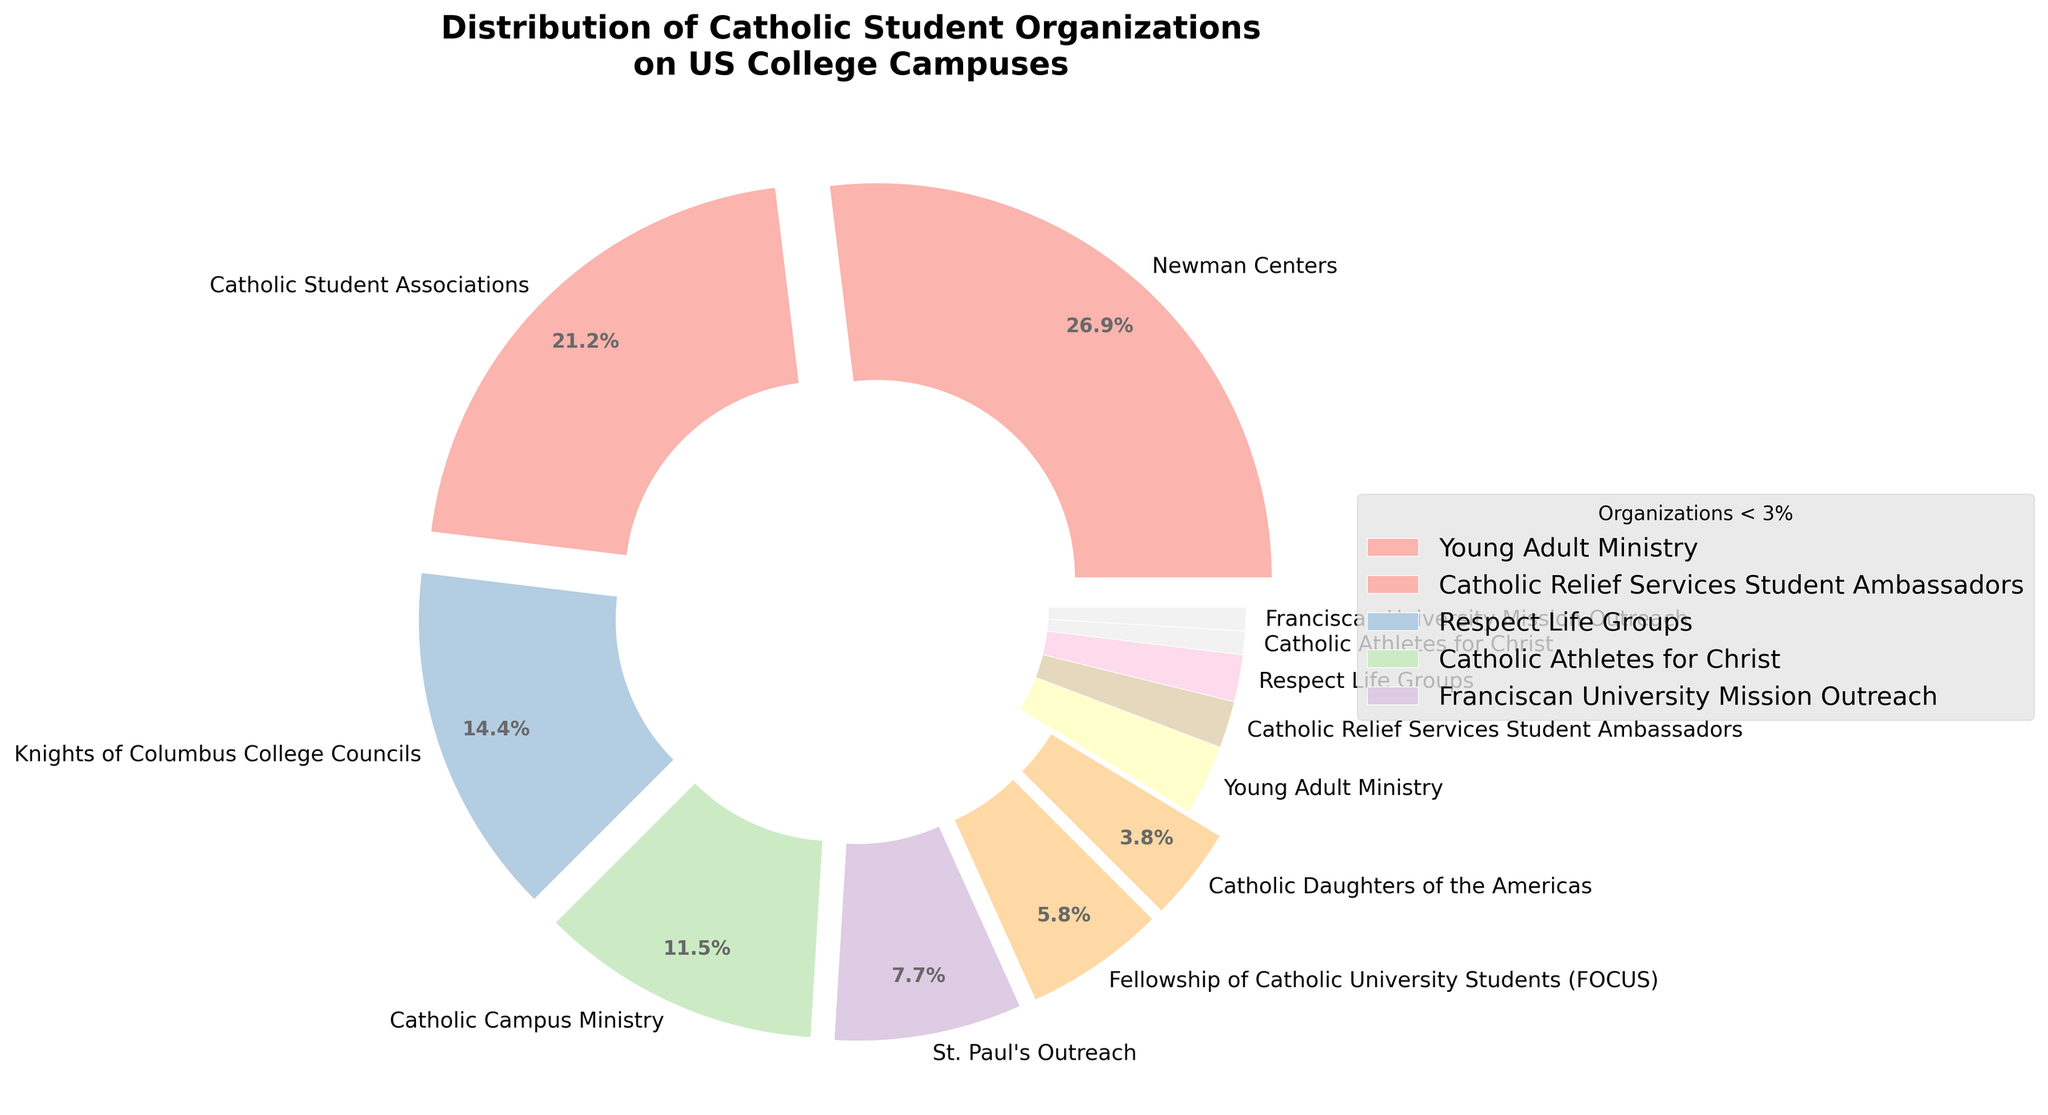Which organization type has the highest percentage? The organization type with the highest percentage is directly visible from the largest wedge of the pie chart.
Answer: Newman Centers What is the combined percentage of Newman Centers and Catholic Student Associations? Add the percentage of Newman Centers (28%) and Catholic Student Associations (22%). 28 + 22 = 50
Answer: 50% Which organizations have a percentage of 2% or less? The legend and the labels on the pie chart identify organizations with a percentage of 2% or less. These are: Catholic Relief Services Student Ambassadors (2%), Respect Life Groups (2%), Catholic Athletes for Christ (1%), Franciscan University Mission Outreach (1%).
Answer: Catholic Relief Services Student Ambassadors, Respect Life Groups, Catholic Athletes for Christ, Franciscan University Mission Outreach Which organization types have their wedges "exploded" or slightly separated from the pie chart? The exploded wedges in the pie chart are those whose sizes are greater than 3%. These are: Newman Centers, Catholic Student Associations, Knights of Columbus College Councils, and Catholic Campus Ministry.
Answer: Newman Centers, Catholic Student Associations, Knights of Columbus College Councils, Catholic Campus Ministry What is the total percentage represented by organizations that have a wedge exploded or separated? Sum up the percentages of Newman Centers (28%), Catholic Student Associations (22%), Knights of Columbus College Councils (15%), and Catholic Campus Ministry (12%). 28 + 22 + 15 + 12 = 77
Answer: 77% How does the size of the wedge for Catholic Daughters of the Americas compare to Young Adult Ministry? Compare the percentages for these two organizations. Catholic Daughters of the Americas has 4% and Young Adult Ministry has 3%, so the wedge for Catholic Daughters of the Americas is larger.
Answer: Catholic Daughters of the Americas is larger What percentage would be needed for St. Paul's Outreach to equal the combined percentage of smaller organizations (≤ 3%)? Sum the percentages of smaller organizations: Young Adult Ministry (3%), Catholic Relief Services Student Ambassadors (2%), Respect Life Groups (2%), Catholic Athletes for Christ (1%), and Franciscan University Mission Outreach (1%). 3 + 2 + 2 + 1 + 1 = 9. St. Paul's Outreach currently has 8%, so it would need 1% more to match that total.
Answer: 1% What is the difference in percentage between the smallest and largest organization types? Subtract the percentage of the smallest organization type (Catholic Athletes for Christ or Franciscan University Mission Outreach at 1%) from the largest organization type (Newman Centers at 28%). 28 - 1 = 27
Answer: 27 How many organization types have a percentage larger than 10%? Refer to the pie chart slices and count the ones with percentages larger than 10%. These are: Newman Centers (28%), Catholic Student Associations (22%), Knights of Columbus College Councils (15%), and Catholic Campus Ministry (12%).
Answer: 4 